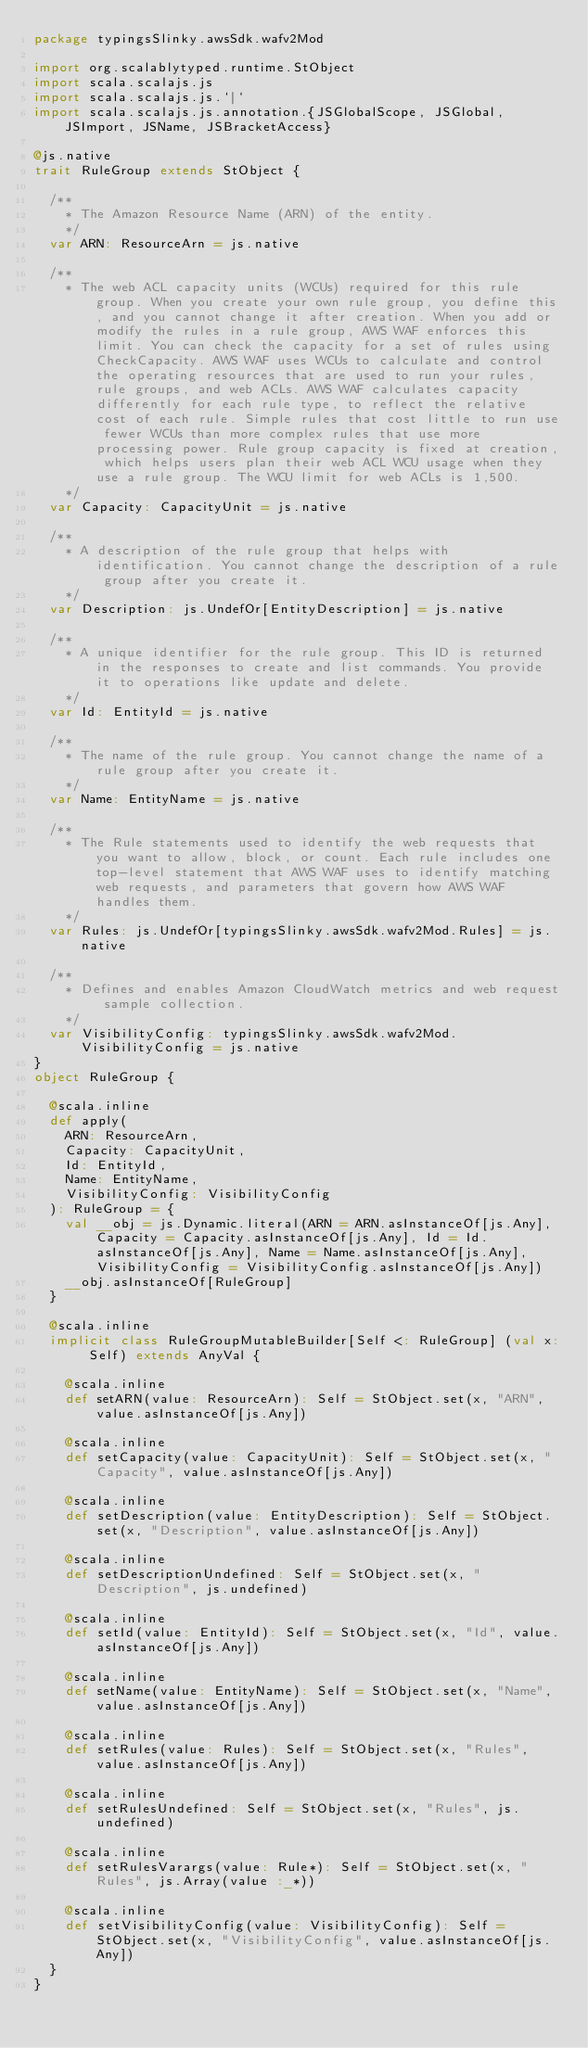Convert code to text. <code><loc_0><loc_0><loc_500><loc_500><_Scala_>package typingsSlinky.awsSdk.wafv2Mod

import org.scalablytyped.runtime.StObject
import scala.scalajs.js
import scala.scalajs.js.`|`
import scala.scalajs.js.annotation.{JSGlobalScope, JSGlobal, JSImport, JSName, JSBracketAccess}

@js.native
trait RuleGroup extends StObject {
  
  /**
    * The Amazon Resource Name (ARN) of the entity.
    */
  var ARN: ResourceArn = js.native
  
  /**
    * The web ACL capacity units (WCUs) required for this rule group. When you create your own rule group, you define this, and you cannot change it after creation. When you add or modify the rules in a rule group, AWS WAF enforces this limit. You can check the capacity for a set of rules using CheckCapacity. AWS WAF uses WCUs to calculate and control the operating resources that are used to run your rules, rule groups, and web ACLs. AWS WAF calculates capacity differently for each rule type, to reflect the relative cost of each rule. Simple rules that cost little to run use fewer WCUs than more complex rules that use more processing power. Rule group capacity is fixed at creation, which helps users plan their web ACL WCU usage when they use a rule group. The WCU limit for web ACLs is 1,500. 
    */
  var Capacity: CapacityUnit = js.native
  
  /**
    * A description of the rule group that helps with identification. You cannot change the description of a rule group after you create it.
    */
  var Description: js.UndefOr[EntityDescription] = js.native
  
  /**
    * A unique identifier for the rule group. This ID is returned in the responses to create and list commands. You provide it to operations like update and delete.
    */
  var Id: EntityId = js.native
  
  /**
    * The name of the rule group. You cannot change the name of a rule group after you create it.
    */
  var Name: EntityName = js.native
  
  /**
    * The Rule statements used to identify the web requests that you want to allow, block, or count. Each rule includes one top-level statement that AWS WAF uses to identify matching web requests, and parameters that govern how AWS WAF handles them. 
    */
  var Rules: js.UndefOr[typingsSlinky.awsSdk.wafv2Mod.Rules] = js.native
  
  /**
    * Defines and enables Amazon CloudWatch metrics and web request sample collection. 
    */
  var VisibilityConfig: typingsSlinky.awsSdk.wafv2Mod.VisibilityConfig = js.native
}
object RuleGroup {
  
  @scala.inline
  def apply(
    ARN: ResourceArn,
    Capacity: CapacityUnit,
    Id: EntityId,
    Name: EntityName,
    VisibilityConfig: VisibilityConfig
  ): RuleGroup = {
    val __obj = js.Dynamic.literal(ARN = ARN.asInstanceOf[js.Any], Capacity = Capacity.asInstanceOf[js.Any], Id = Id.asInstanceOf[js.Any], Name = Name.asInstanceOf[js.Any], VisibilityConfig = VisibilityConfig.asInstanceOf[js.Any])
    __obj.asInstanceOf[RuleGroup]
  }
  
  @scala.inline
  implicit class RuleGroupMutableBuilder[Self <: RuleGroup] (val x: Self) extends AnyVal {
    
    @scala.inline
    def setARN(value: ResourceArn): Self = StObject.set(x, "ARN", value.asInstanceOf[js.Any])
    
    @scala.inline
    def setCapacity(value: CapacityUnit): Self = StObject.set(x, "Capacity", value.asInstanceOf[js.Any])
    
    @scala.inline
    def setDescription(value: EntityDescription): Self = StObject.set(x, "Description", value.asInstanceOf[js.Any])
    
    @scala.inline
    def setDescriptionUndefined: Self = StObject.set(x, "Description", js.undefined)
    
    @scala.inline
    def setId(value: EntityId): Self = StObject.set(x, "Id", value.asInstanceOf[js.Any])
    
    @scala.inline
    def setName(value: EntityName): Self = StObject.set(x, "Name", value.asInstanceOf[js.Any])
    
    @scala.inline
    def setRules(value: Rules): Self = StObject.set(x, "Rules", value.asInstanceOf[js.Any])
    
    @scala.inline
    def setRulesUndefined: Self = StObject.set(x, "Rules", js.undefined)
    
    @scala.inline
    def setRulesVarargs(value: Rule*): Self = StObject.set(x, "Rules", js.Array(value :_*))
    
    @scala.inline
    def setVisibilityConfig(value: VisibilityConfig): Self = StObject.set(x, "VisibilityConfig", value.asInstanceOf[js.Any])
  }
}
</code> 